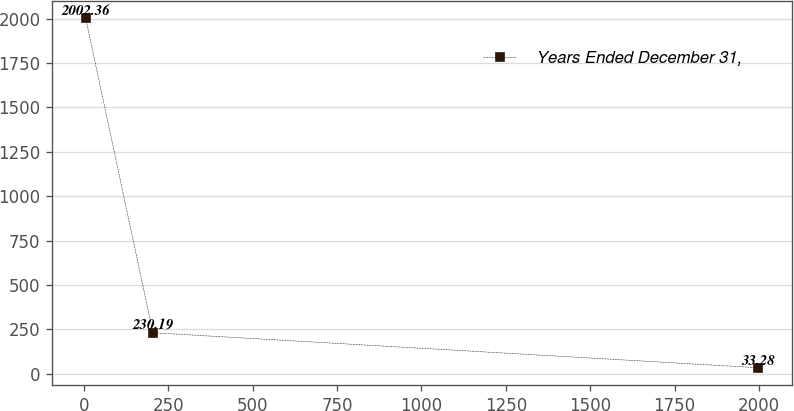<chart> <loc_0><loc_0><loc_500><loc_500><line_chart><ecel><fcel>Years Ended December 31,<nl><fcel>5.72<fcel>2002.36<nl><fcel>204.88<fcel>230.19<nl><fcel>1997.35<fcel>33.28<nl></chart> 